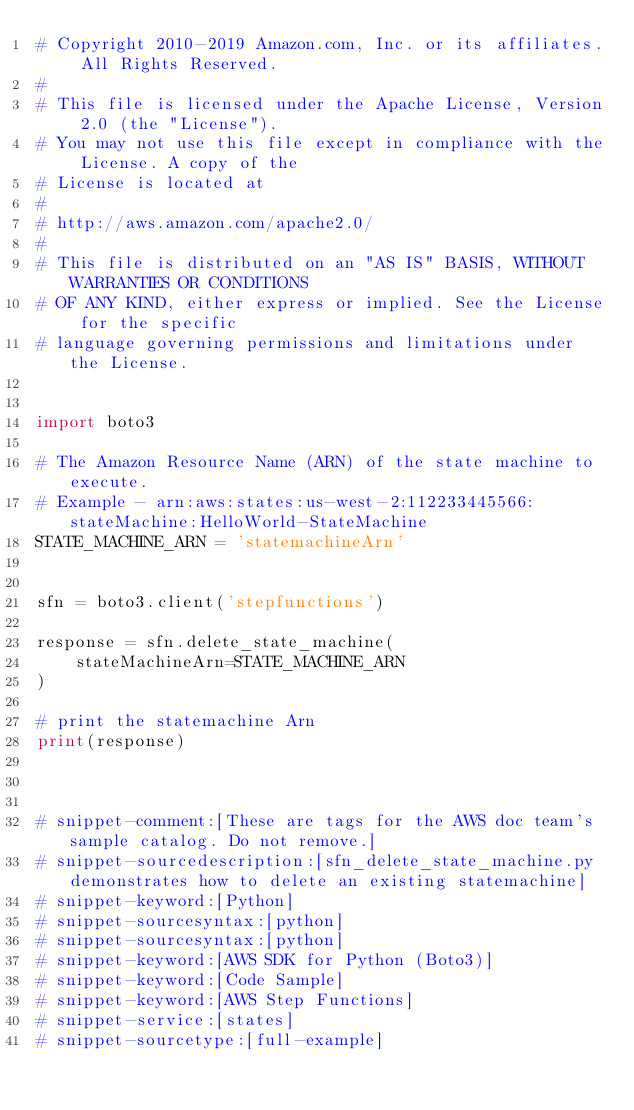Convert code to text. <code><loc_0><loc_0><loc_500><loc_500><_Python_># Copyright 2010-2019 Amazon.com, Inc. or its affiliates. All Rights Reserved.
#
# This file is licensed under the Apache License, Version 2.0 (the "License").
# You may not use this file except in compliance with the License. A copy of the
# License is located at
#
# http://aws.amazon.com/apache2.0/
#
# This file is distributed on an "AS IS" BASIS, WITHOUT WARRANTIES OR CONDITIONS
# OF ANY KIND, either express or implied. See the License for the specific
# language governing permissions and limitations under the License.


import boto3

# The Amazon Resource Name (ARN) of the state machine to execute.
# Example - arn:aws:states:us-west-2:112233445566:stateMachine:HelloWorld-StateMachine
STATE_MACHINE_ARN = 'statemachineArn'


sfn = boto3.client('stepfunctions')

response = sfn.delete_state_machine(
    stateMachineArn=STATE_MACHINE_ARN
)

# print the statemachine Arn
print(response)



# snippet-comment:[These are tags for the AWS doc team's sample catalog. Do not remove.]
# snippet-sourcedescription:[sfn_delete_state_machine.py demonstrates how to delete an existing statemachine]
# snippet-keyword:[Python]
# snippet-sourcesyntax:[python]
# snippet-sourcesyntax:[python]
# snippet-keyword:[AWS SDK for Python (Boto3)]
# snippet-keyword:[Code Sample]
# snippet-keyword:[AWS Step Functions]
# snippet-service:[states]
# snippet-sourcetype:[full-example]</code> 